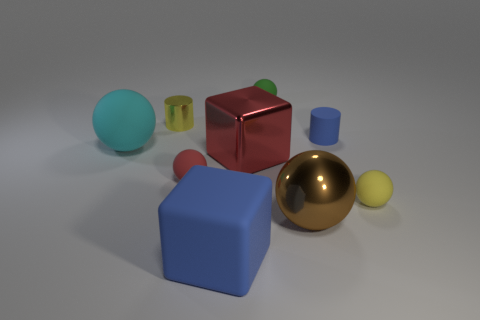There is a metallic thing that is on the left side of the red cube; is there a tiny matte object in front of it?
Your answer should be compact. Yes. Is the number of green matte spheres that are in front of the brown metallic thing less than the number of red things that are to the right of the matte block?
Ensure brevity in your answer.  Yes. Do the red thing to the left of the big matte cube and the small cylinder that is to the right of the green thing have the same material?
Your answer should be compact. Yes. What number of small things are yellow rubber spheres or green rubber things?
Make the answer very short. 2. There is a big cyan thing that is made of the same material as the small blue object; what is its shape?
Keep it short and to the point. Sphere. Are there fewer big red objects on the left side of the blue matte block than green rubber objects?
Offer a very short reply. Yes. Is the shape of the tiny yellow matte thing the same as the cyan matte thing?
Your response must be concise. Yes. What number of shiny things are large green spheres or tiny blue cylinders?
Provide a succinct answer. 0. Is there a matte block that has the same size as the blue rubber cylinder?
Give a very brief answer. No. There is a matte object that is the same color as the metallic cylinder; what is its shape?
Offer a very short reply. Sphere. 